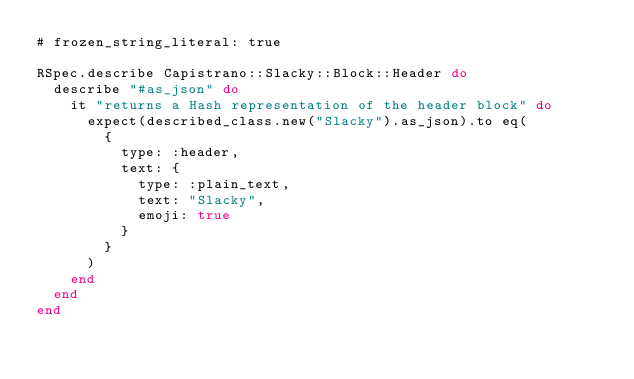<code> <loc_0><loc_0><loc_500><loc_500><_Ruby_># frozen_string_literal: true

RSpec.describe Capistrano::Slacky::Block::Header do
  describe "#as_json" do
    it "returns a Hash representation of the header block" do
      expect(described_class.new("Slacky").as_json).to eq(
        {
          type: :header,
          text: {
            type: :plain_text,
            text: "Slacky",
            emoji: true
          }
        }
      )
    end
  end
end
</code> 